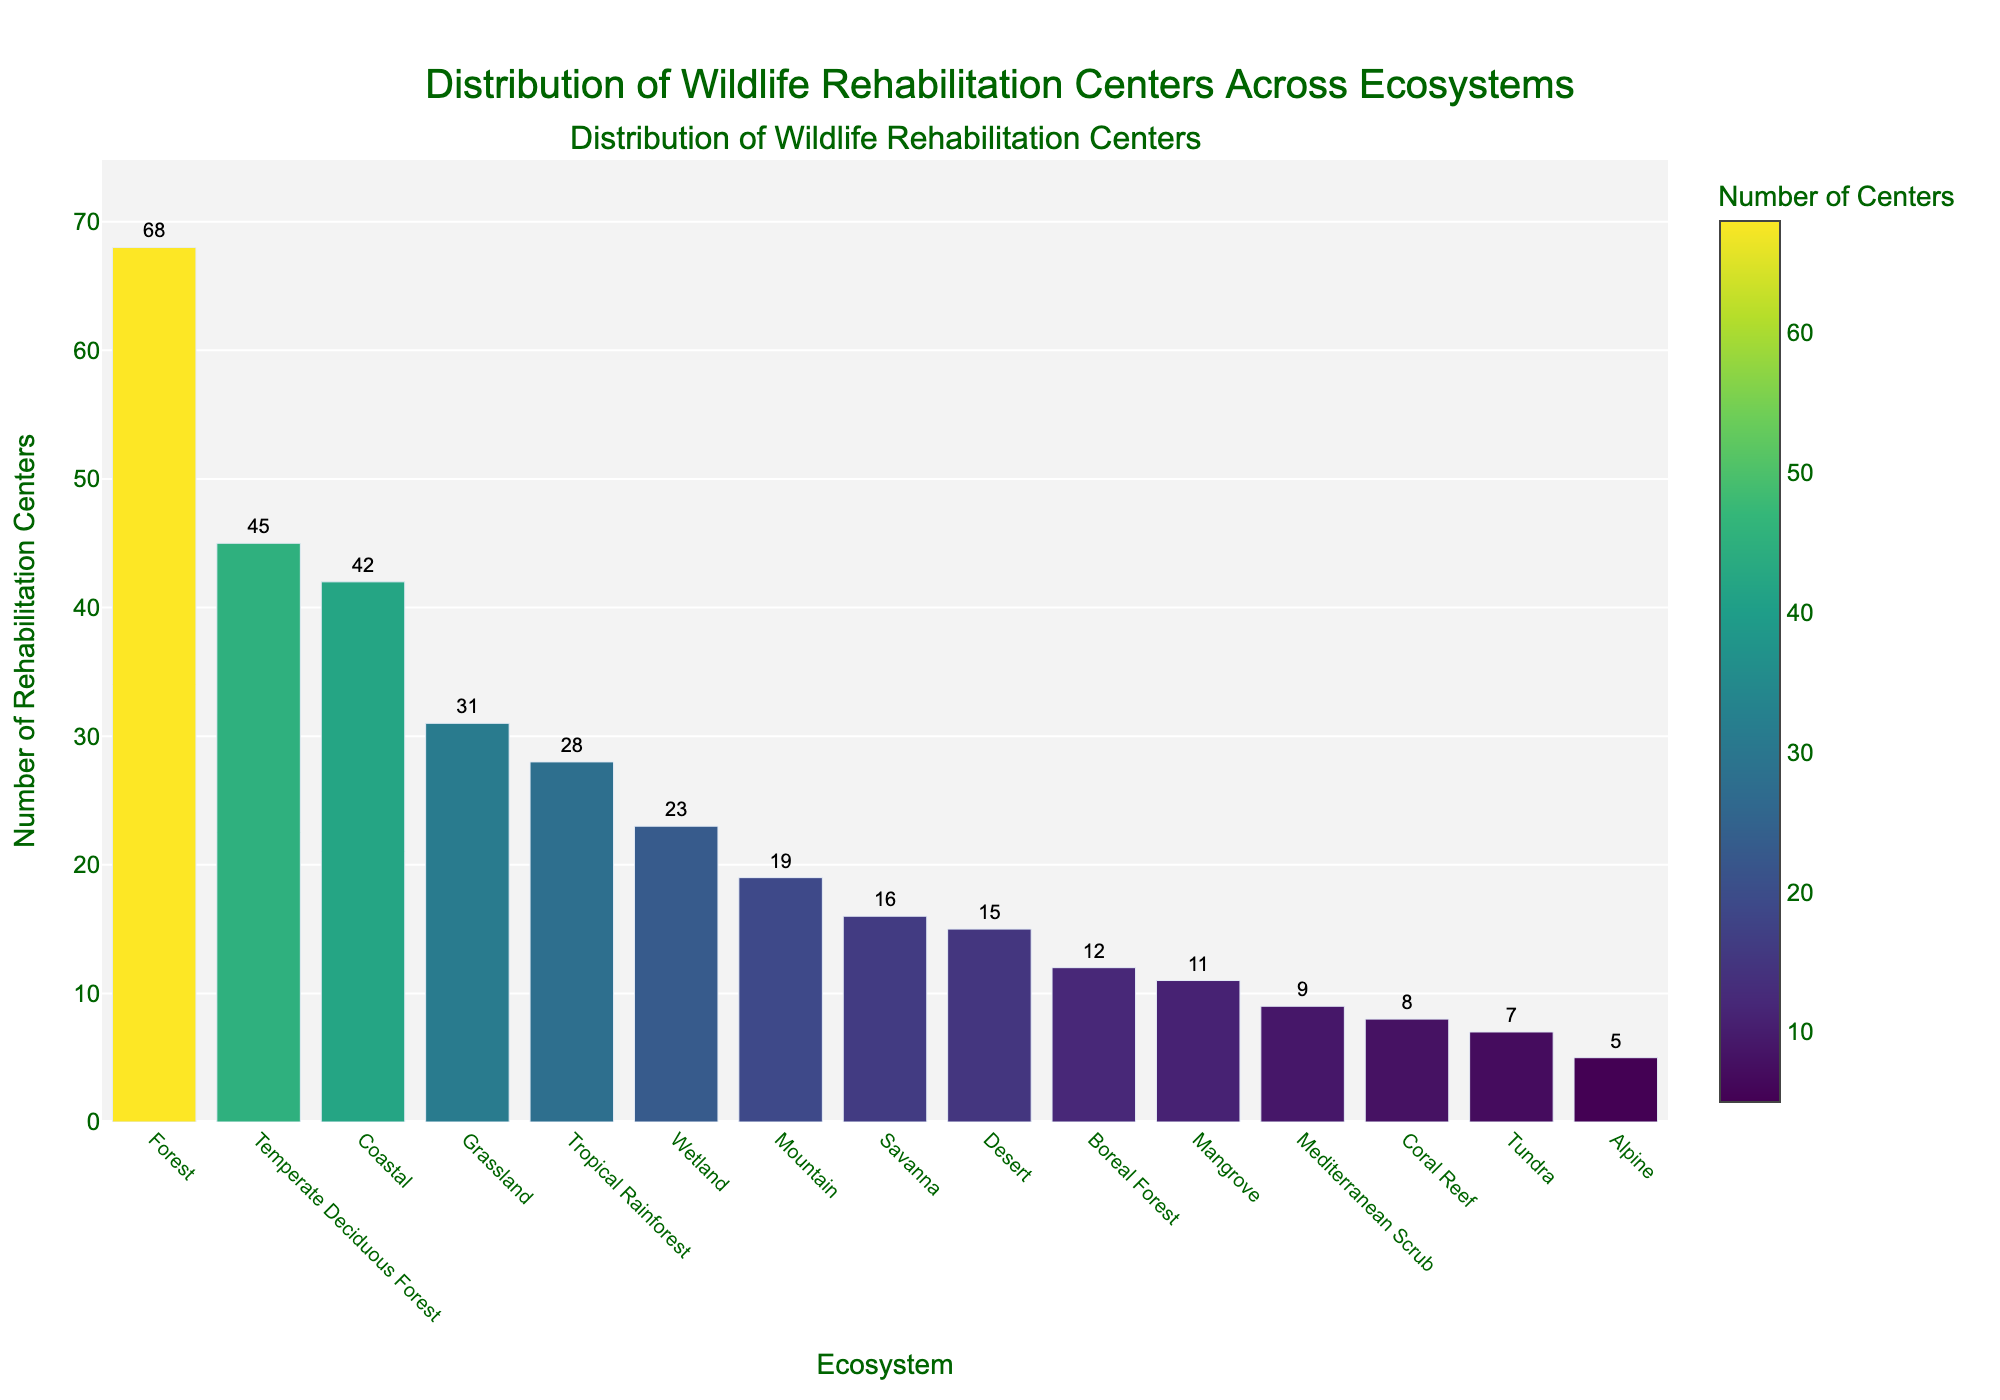Which ecosystem has the highest number of rehabilitation centers? The bar for the Forest ecosystem is the tallest, indicating it has the highest number of rehabilitation centers.
Answer: Forest Which two ecosystems have the closest number of rehabilitation centers? The bars for Savanna and Desert ecosystems are very close in height, indicating they have a similar number of rehabilitation centers.
Answer: Savanna and Desert What is the total number of rehabilitation centers for Coastal and Forest ecosystems combined? The number of rehabilitation centers for Coastal is 42 and for Forest is 68. Summing these values gives 42 + 68 = 110.
Answer: 110 How many more rehabilitation centers are there in Temperate Deciduous Forest compared to Boreal Forest? The number of rehabilitation centers in Temperate Deciduous Forest is 45, and in Boreal Forest, it is 12. The difference is 45 - 12 = 33.
Answer: 33 Which ecosystem has fewer rehabilitation centers, Tundra or Coral Reef? The bar for Tundra is shorter than the bar for Coral Reef, indicating Tundra has fewer rehabilitation centers.
Answer: Tundra What is the average number of rehabilitation centers across all ecosystems? Summing all the values: 42 + 68 + 31 + 23 + 15 + 7 + 19 + 28 + 45 + 12 + 16 + 9 + 5 + 11 + 8 = 339. The number of ecosystems is 15. The average is 339 / 15 ≈ 22.6.
Answer: 22.6 How does the number of rehabilitation centers in Wetlands compare to that in Grasslands? The bar for Wetland (23) is shorter than the bar for Grassland (31), indicating that Wetland has fewer rehabilitation centers.
Answer: Wetlands have fewer centers Which three ecosystems have the lowest number of rehabilitation centers? The bars for Alpine, Tundra, and Coral Reef are the shortest, indicating they have the lowest number of rehabilitation centers, with counts of 5, 7, and 8 respectively.
Answer: Alpine, Tundra, Coral Reef 